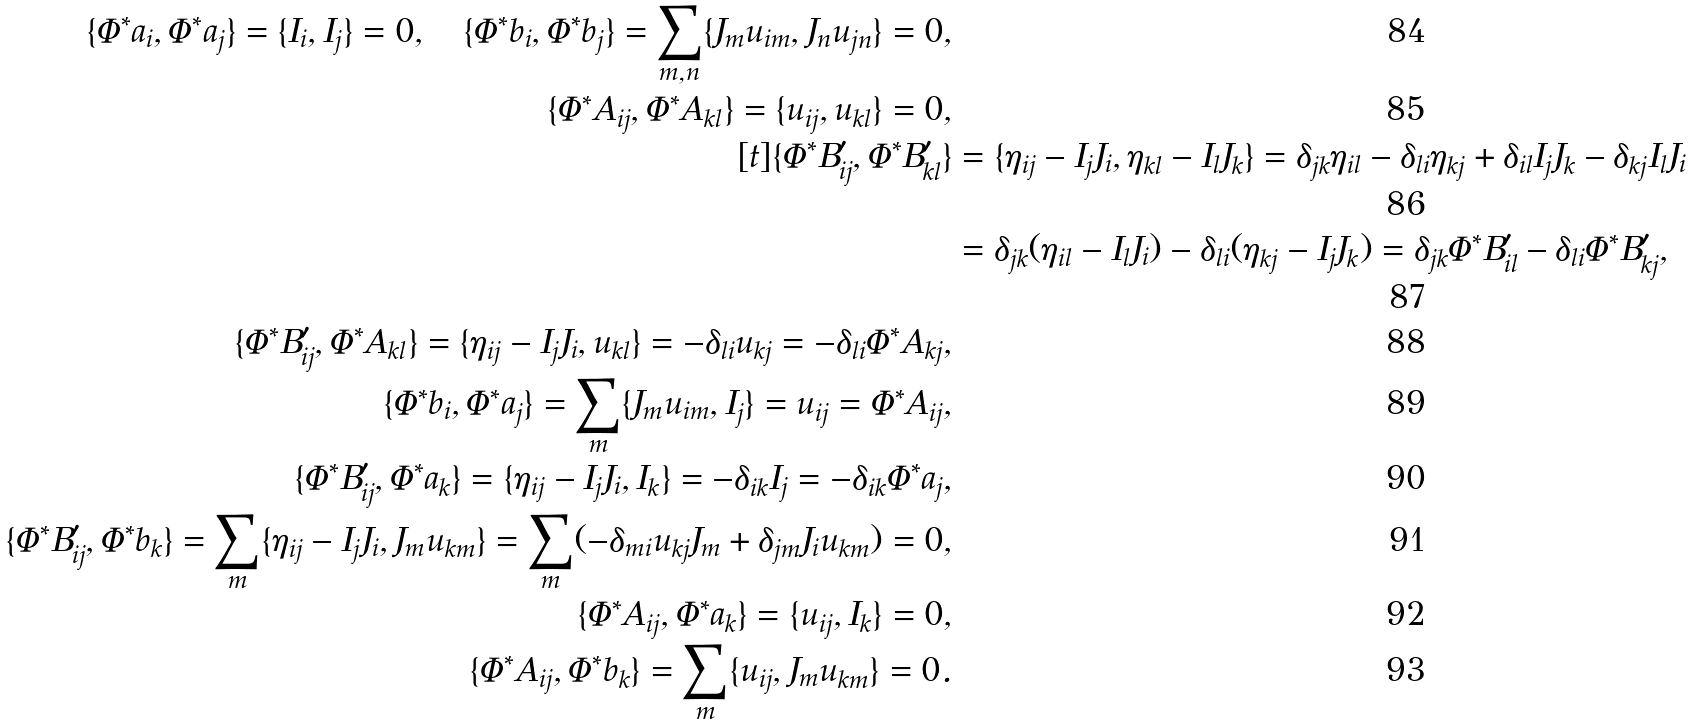<formula> <loc_0><loc_0><loc_500><loc_500>\{ \Phi ^ { * } a _ { i } , \Phi ^ { * } a _ { j } \} = \{ I _ { i } , I _ { j } \} = 0 , \quad \{ \Phi ^ { * } b _ { i } , \Phi ^ { * } b _ { j } \} = \sum _ { m , n } \{ J _ { m } u _ { i m } , J _ { n } u _ { j n } \} = 0 , \\ \{ \Phi ^ { * } A _ { i j } , \Phi ^ { * } A _ { k l } \} = \{ u _ { i j } , u _ { k l } \} = 0 , \\ [ t ] \{ \Phi ^ { * } B ^ { \prime } _ { i j } , \Phi ^ { * } B ^ { \prime } _ { k l } \} & = \{ \eta _ { i j } - I _ { j } J _ { i } , \eta _ { k l } - I _ { l } J _ { k } \} = \delta _ { j k } \eta _ { i l } - \delta _ { l i } \eta _ { k j } + \delta _ { i l } I _ { j } J _ { k } - \delta _ { k j } I _ { l } J _ { i } \\ & = \delta _ { j k } ( \eta _ { i l } - I _ { l } J _ { i } ) - \delta _ { l i } ( \eta _ { k j } - I _ { j } J _ { k } ) = \delta _ { j k } \Phi ^ { * } B ^ { \prime } _ { i l } - \delta _ { l i } \Phi ^ { * } B ^ { \prime } _ { k j } , \\ \{ \Phi ^ { * } B ^ { \prime } _ { i j } , \Phi ^ { * } A _ { k l } \} = \{ \eta _ { i j } - I _ { j } J _ { i } , u _ { k l } \} = - \delta _ { l i } u _ { k j } = - \delta _ { l i } \Phi ^ { * } A _ { k j } , \\ \{ \Phi ^ { * } b _ { i } , \Phi ^ { * } a _ { j } \} = \sum _ { m } \{ J _ { m } u _ { i m } , I _ { j } \} = u _ { i j } = \Phi ^ { * } A _ { i j } , \\ \{ \Phi ^ { * } B ^ { \prime } _ { i j } , \Phi ^ { * } a _ { k } \} = \{ \eta _ { i j } - I _ { j } J _ { i } , I _ { k } \} = - \delta _ { i k } I _ { j } = - \delta _ { i k } \Phi ^ { * } a _ { j } , \\ \{ \Phi ^ { * } B ^ { \prime } _ { i j } , \Phi ^ { * } b _ { k } \} = \sum _ { m } \{ \eta _ { i j } - I _ { j } J _ { i } , J _ { m } u _ { k m } \} = \sum _ { m } ( - \delta _ { m i } u _ { k j } J _ { m } + \delta _ { j m } J _ { i } u _ { k m } ) = 0 , \\ \{ \Phi ^ { * } A _ { i j } , \Phi ^ { * } a _ { k } \} = \{ u _ { i j } , I _ { k } \} = 0 , \\ \{ \Phi ^ { * } A _ { i j } , \Phi ^ { * } b _ { k } \} = \sum _ { m } \{ u _ { i j } , J _ { m } u _ { k m } \} = 0 .</formula> 